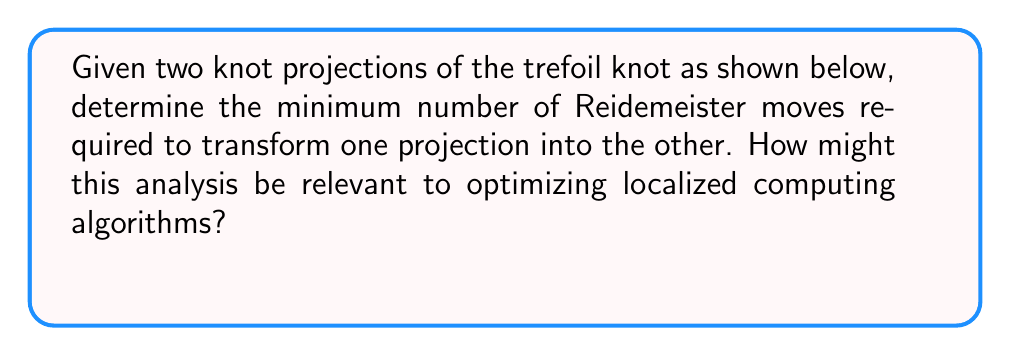Solve this math problem. To analyze the Reidemeister moves required to transform one trefoil knot projection into another, we need to understand the three types of Reidemeister moves:

1. Type I: Twisting or untwisting a strand
2. Type II: Moving one strand completely over another
3. Type III: Moving a strand over or under a crossing

Let's analyze the transformations step-by-step:

1. Observe that Projection A is a right-handed trefoil, while Projection B is a left-handed trefoil.

2. To transform a right-handed trefoil into a left-handed trefoil, we need to change the "handedness" of each crossing. This requires three Type III Reidemeister moves, one for each crossing.

3. For each crossing:
   a. Apply a Type III move to slide the overcrossing strand under the adjacent crossing.
   b. This effectively changes the handedness of that particular crossing.

4. After applying three Type III moves, we will have transformed Projection A into Projection B.

The minimum number of Reidemeister moves required is 3.

Relevance to optimizing localized computing algorithms:

1. Reidemeister moves can be seen as local transformations of a global structure (the knot).

2. In localized computing, we often need to make local changes that affect the global state of the system.

3. Understanding the minimum number of local transformations (Reidemeister moves) needed to change a global state (knot projection) can help in designing efficient algorithms for distributed systems.

4. This analysis demonstrates how complex global changes can be achieved through a series of simple local operations, which is a key principle in designing scalable and efficient localized computing solutions.

5. The concept of minimizing the number of moves can be applied to optimizing communication protocols or data transformation processes in distributed systems, reducing overall computational complexity and network traffic.
Answer: 3 Type III Reidemeister moves 